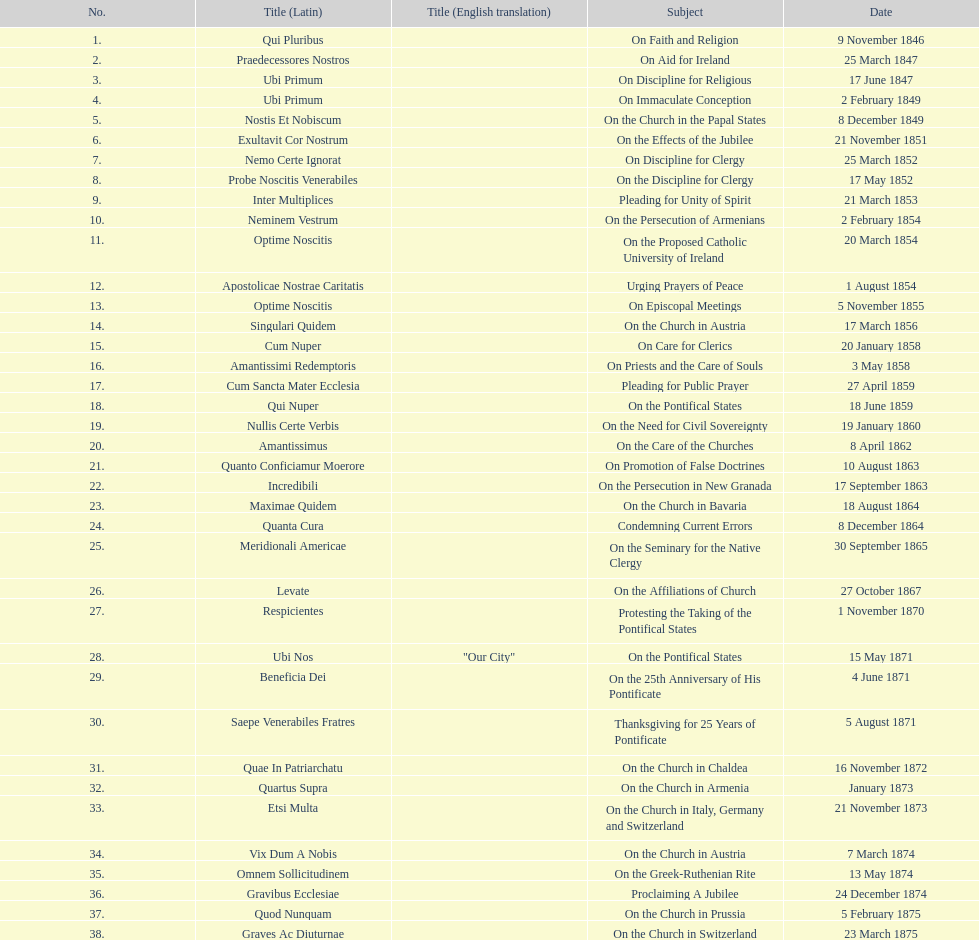What is the total number of title? 38. Could you parse the entire table as a dict? {'header': ['No.', 'Title (Latin)', 'Title (English translation)', 'Subject', 'Date'], 'rows': [['1.', 'Qui Pluribus', '', 'On Faith and Religion', '9 November 1846'], ['2.', 'Praedecessores Nostros', '', 'On Aid for Ireland', '25 March 1847'], ['3.', 'Ubi Primum', '', 'On Discipline for Religious', '17 June 1847'], ['4.', 'Ubi Primum', '', 'On Immaculate Conception', '2 February 1849'], ['5.', 'Nostis Et Nobiscum', '', 'On the Church in the Papal States', '8 December 1849'], ['6.', 'Exultavit Cor Nostrum', '', 'On the Effects of the Jubilee', '21 November 1851'], ['7.', 'Nemo Certe Ignorat', '', 'On Discipline for Clergy', '25 March 1852'], ['8.', 'Probe Noscitis Venerabiles', '', 'On the Discipline for Clergy', '17 May 1852'], ['9.', 'Inter Multiplices', '', 'Pleading for Unity of Spirit', '21 March 1853'], ['10.', 'Neminem Vestrum', '', 'On the Persecution of Armenians', '2 February 1854'], ['11.', 'Optime Noscitis', '', 'On the Proposed Catholic University of Ireland', '20 March 1854'], ['12.', 'Apostolicae Nostrae Caritatis', '', 'Urging Prayers of Peace', '1 August 1854'], ['13.', 'Optime Noscitis', '', 'On Episcopal Meetings', '5 November 1855'], ['14.', 'Singulari Quidem', '', 'On the Church in Austria', '17 March 1856'], ['15.', 'Cum Nuper', '', 'On Care for Clerics', '20 January 1858'], ['16.', 'Amantissimi Redemptoris', '', 'On Priests and the Care of Souls', '3 May 1858'], ['17.', 'Cum Sancta Mater Ecclesia', '', 'Pleading for Public Prayer', '27 April 1859'], ['18.', 'Qui Nuper', '', 'On the Pontifical States', '18 June 1859'], ['19.', 'Nullis Certe Verbis', '', 'On the Need for Civil Sovereignty', '19 January 1860'], ['20.', 'Amantissimus', '', 'On the Care of the Churches', '8 April 1862'], ['21.', 'Quanto Conficiamur Moerore', '', 'On Promotion of False Doctrines', '10 August 1863'], ['22.', 'Incredibili', '', 'On the Persecution in New Granada', '17 September 1863'], ['23.', 'Maximae Quidem', '', 'On the Church in Bavaria', '18 August 1864'], ['24.', 'Quanta Cura', '', 'Condemning Current Errors', '8 December 1864'], ['25.', 'Meridionali Americae', '', 'On the Seminary for the Native Clergy', '30 September 1865'], ['26.', 'Levate', '', 'On the Affiliations of Church', '27 October 1867'], ['27.', 'Respicientes', '', 'Protesting the Taking of the Pontifical States', '1 November 1870'], ['28.', 'Ubi Nos', '"Our City"', 'On the Pontifical States', '15 May 1871'], ['29.', 'Beneficia Dei', '', 'On the 25th Anniversary of His Pontificate', '4 June 1871'], ['30.', 'Saepe Venerabiles Fratres', '', 'Thanksgiving for 25 Years of Pontificate', '5 August 1871'], ['31.', 'Quae In Patriarchatu', '', 'On the Church in Chaldea', '16 November 1872'], ['32.', 'Quartus Supra', '', 'On the Church in Armenia', 'January 1873'], ['33.', 'Etsi Multa', '', 'On the Church in Italy, Germany and Switzerland', '21 November 1873'], ['34.', 'Vix Dum A Nobis', '', 'On the Church in Austria', '7 March 1874'], ['35.', 'Omnem Sollicitudinem', '', 'On the Greek-Ruthenian Rite', '13 May 1874'], ['36.', 'Gravibus Ecclesiae', '', 'Proclaiming A Jubilee', '24 December 1874'], ['37.', 'Quod Nunquam', '', 'On the Church in Prussia', '5 February 1875'], ['38.', 'Graves Ac Diuturnae', '', 'On the Church in Switzerland', '23 March 1875']]} 